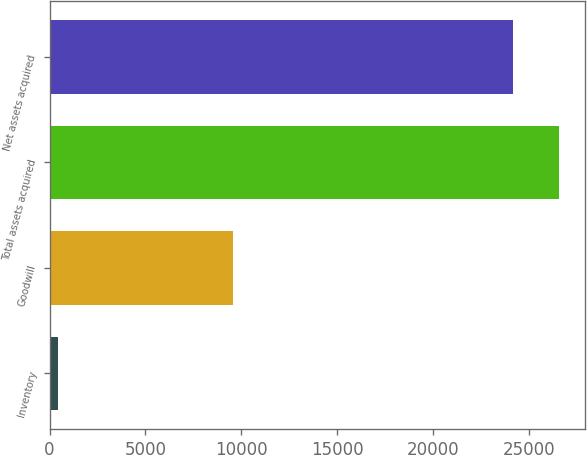Convert chart. <chart><loc_0><loc_0><loc_500><loc_500><bar_chart><fcel>Inventory<fcel>Goodwill<fcel>Total assets acquired<fcel>Net assets acquired<nl><fcel>442<fcel>9575<fcel>26577.3<fcel>24180<nl></chart> 